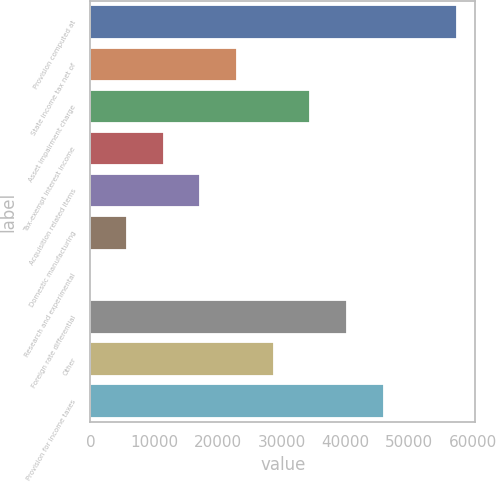<chart> <loc_0><loc_0><loc_500><loc_500><bar_chart><fcel>Provision computed at<fcel>State income tax net of<fcel>Asset impairment charge<fcel>Tax-exempt interest income<fcel>Acquisition related items<fcel>Domestic manufacturing<fcel>Research and experimental<fcel>Foreign rate differential<fcel>Other<fcel>Provision for income taxes<nl><fcel>57461<fcel>22985.8<fcel>34477.5<fcel>11494.1<fcel>17240<fcel>5748.24<fcel>2.38<fcel>40223.4<fcel>28731.7<fcel>45969.3<nl></chart> 